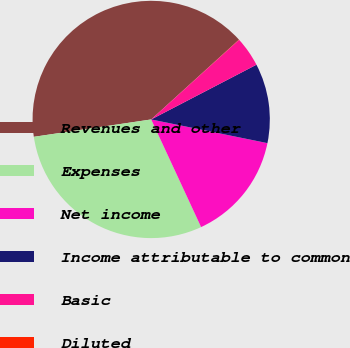<chart> <loc_0><loc_0><loc_500><loc_500><pie_chart><fcel>Revenues and other<fcel>Expenses<fcel>Net income<fcel>Income attributable to common<fcel>Basic<fcel>Diluted<nl><fcel>40.59%<fcel>29.57%<fcel>14.89%<fcel>10.83%<fcel>4.08%<fcel>0.03%<nl></chart> 